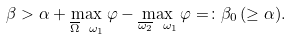Convert formula to latex. <formula><loc_0><loc_0><loc_500><loc_500>\beta > \alpha + \max _ { \overline { \Omega } \ \omega _ { 1 } } \varphi - \max _ { \overline { \omega _ { 2 } } \ \omega _ { 1 } } \varphi = \colon \beta _ { 0 } \, ( \geq \alpha ) .</formula> 